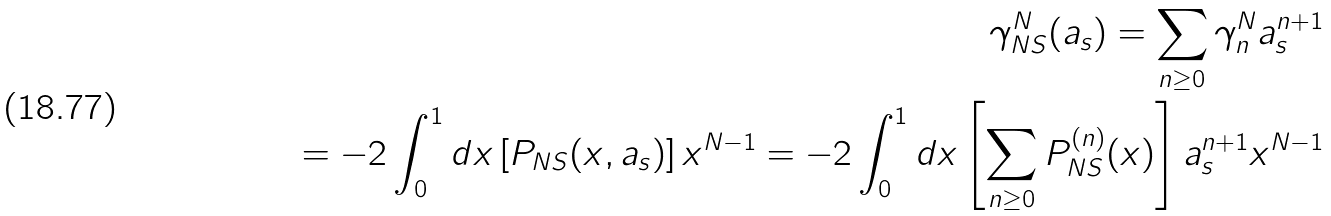<formula> <loc_0><loc_0><loc_500><loc_500>\gamma _ { N S } ^ { N } ( a _ { s } ) = \sum _ { n \geq 0 } \gamma _ { n } ^ { N } a _ { s } ^ { n + 1 } \\ = - 2 \int _ { 0 } ^ { 1 } d x \left [ P _ { N S } ( x , a _ { s } ) \right ] { x } ^ { N - 1 } = - 2 \int _ { 0 } ^ { 1 } d x \left [ \sum _ { n \geq 0 } P _ { N S } ^ { ( n ) } ( x ) \right ] a _ { s } ^ { n + 1 } { x } ^ { N - 1 }</formula> 